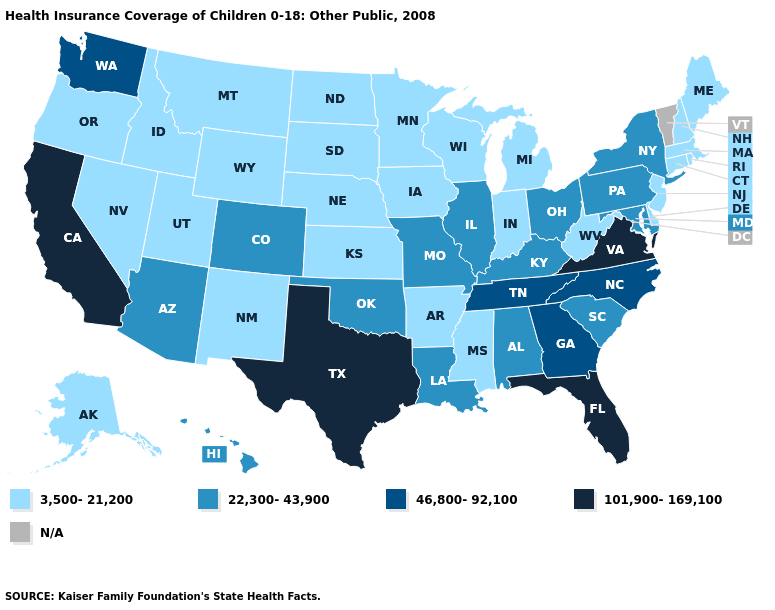Does the map have missing data?
Answer briefly. Yes. Is the legend a continuous bar?
Be succinct. No. Among the states that border Texas , which have the lowest value?
Be succinct. Arkansas, New Mexico. Among the states that border Idaho , does Utah have the lowest value?
Give a very brief answer. Yes. Name the states that have a value in the range 101,900-169,100?
Short answer required. California, Florida, Texas, Virginia. Which states have the lowest value in the South?
Keep it brief. Arkansas, Delaware, Mississippi, West Virginia. Among the states that border Delaware , does Maryland have the highest value?
Be succinct. Yes. What is the value of Wyoming?
Be succinct. 3,500-21,200. Which states have the lowest value in the USA?
Be succinct. Alaska, Arkansas, Connecticut, Delaware, Idaho, Indiana, Iowa, Kansas, Maine, Massachusetts, Michigan, Minnesota, Mississippi, Montana, Nebraska, Nevada, New Hampshire, New Jersey, New Mexico, North Dakota, Oregon, Rhode Island, South Dakota, Utah, West Virginia, Wisconsin, Wyoming. Name the states that have a value in the range 46,800-92,100?
Concise answer only. Georgia, North Carolina, Tennessee, Washington. What is the highest value in states that border Utah?
Quick response, please. 22,300-43,900. Among the states that border Kentucky , which have the highest value?
Keep it brief. Virginia. 